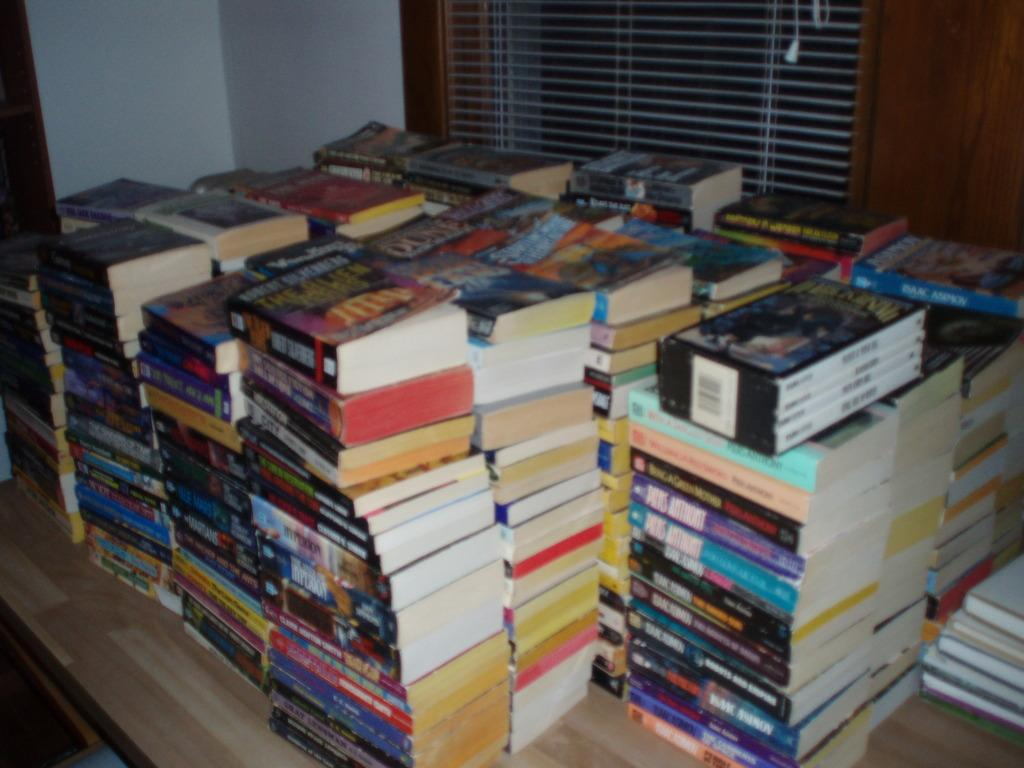What is the main subject in the center of the image? There is a platform in the center of the image. What can be seen on the platform? There are different types of books on the platform. What is visible in the background of the image? There is a wall and a window blind in the background of the image. What company is responsible for the heat in the image? There is no mention of heat or a company in the image. The image only shows a platform with books and a background with a wall and a window blind. 